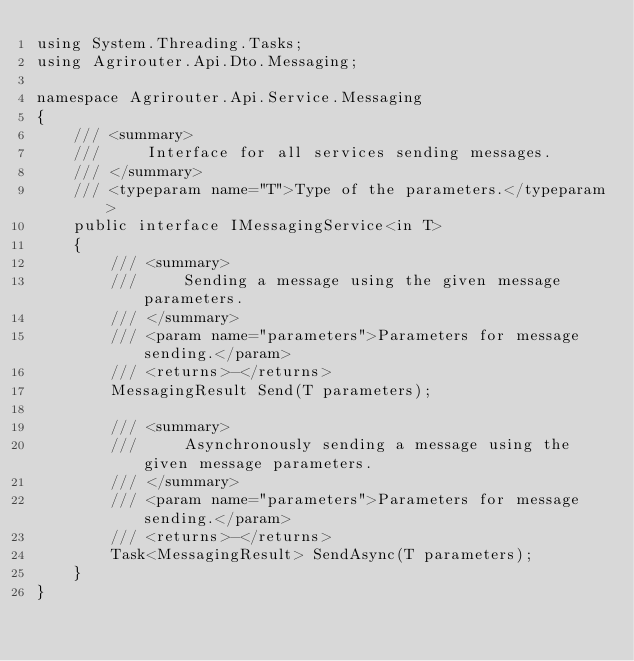<code> <loc_0><loc_0><loc_500><loc_500><_C#_>using System.Threading.Tasks;
using Agrirouter.Api.Dto.Messaging;

namespace Agrirouter.Api.Service.Messaging
{
    /// <summary>
    ///     Interface for all services sending messages.
    /// </summary>
    /// <typeparam name="T">Type of the parameters.</typeparam>
    public interface IMessagingService<in T>
    {
        /// <summary>
        ///     Sending a message using the given message parameters.
        /// </summary>
        /// <param name="parameters">Parameters for message sending.</param>
        /// <returns>-</returns>
        MessagingResult Send(T parameters);

        /// <summary>
        ///     Asynchronously sending a message using the given message parameters.
        /// </summary>
        /// <param name="parameters">Parameters for message sending.</param>
        /// <returns>-</returns>
        Task<MessagingResult> SendAsync(T parameters);
    }
}</code> 